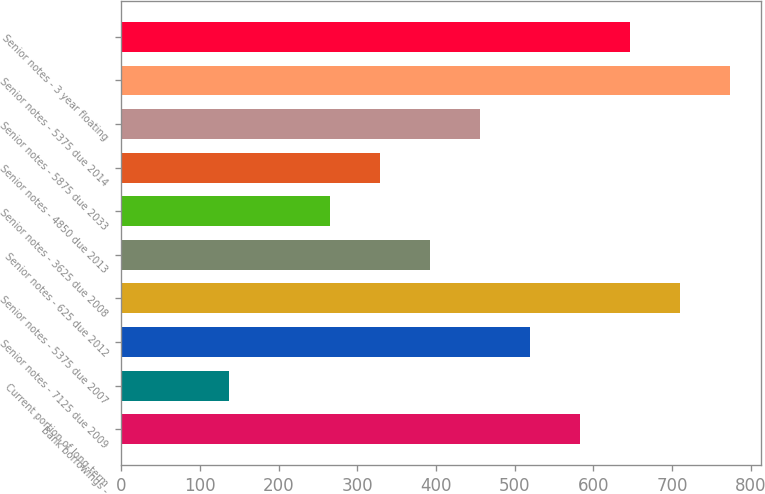Convert chart to OTSL. <chart><loc_0><loc_0><loc_500><loc_500><bar_chart><fcel>Bank borrowings -<fcel>Current portion of long-term<fcel>Senior notes - 7125 due 2009<fcel>Senior notes - 5375 due 2007<fcel>Senior notes - 625 due 2012<fcel>Senior notes - 3625 due 2008<fcel>Senior notes - 4850 due 2013<fcel>Senior notes - 5875 due 2033<fcel>Senior notes - 5375 due 2014<fcel>Senior notes - 3 year floating<nl><fcel>583.3<fcel>137.4<fcel>519.6<fcel>710.7<fcel>392.2<fcel>264.8<fcel>328.5<fcel>455.9<fcel>774.4<fcel>647<nl></chart> 